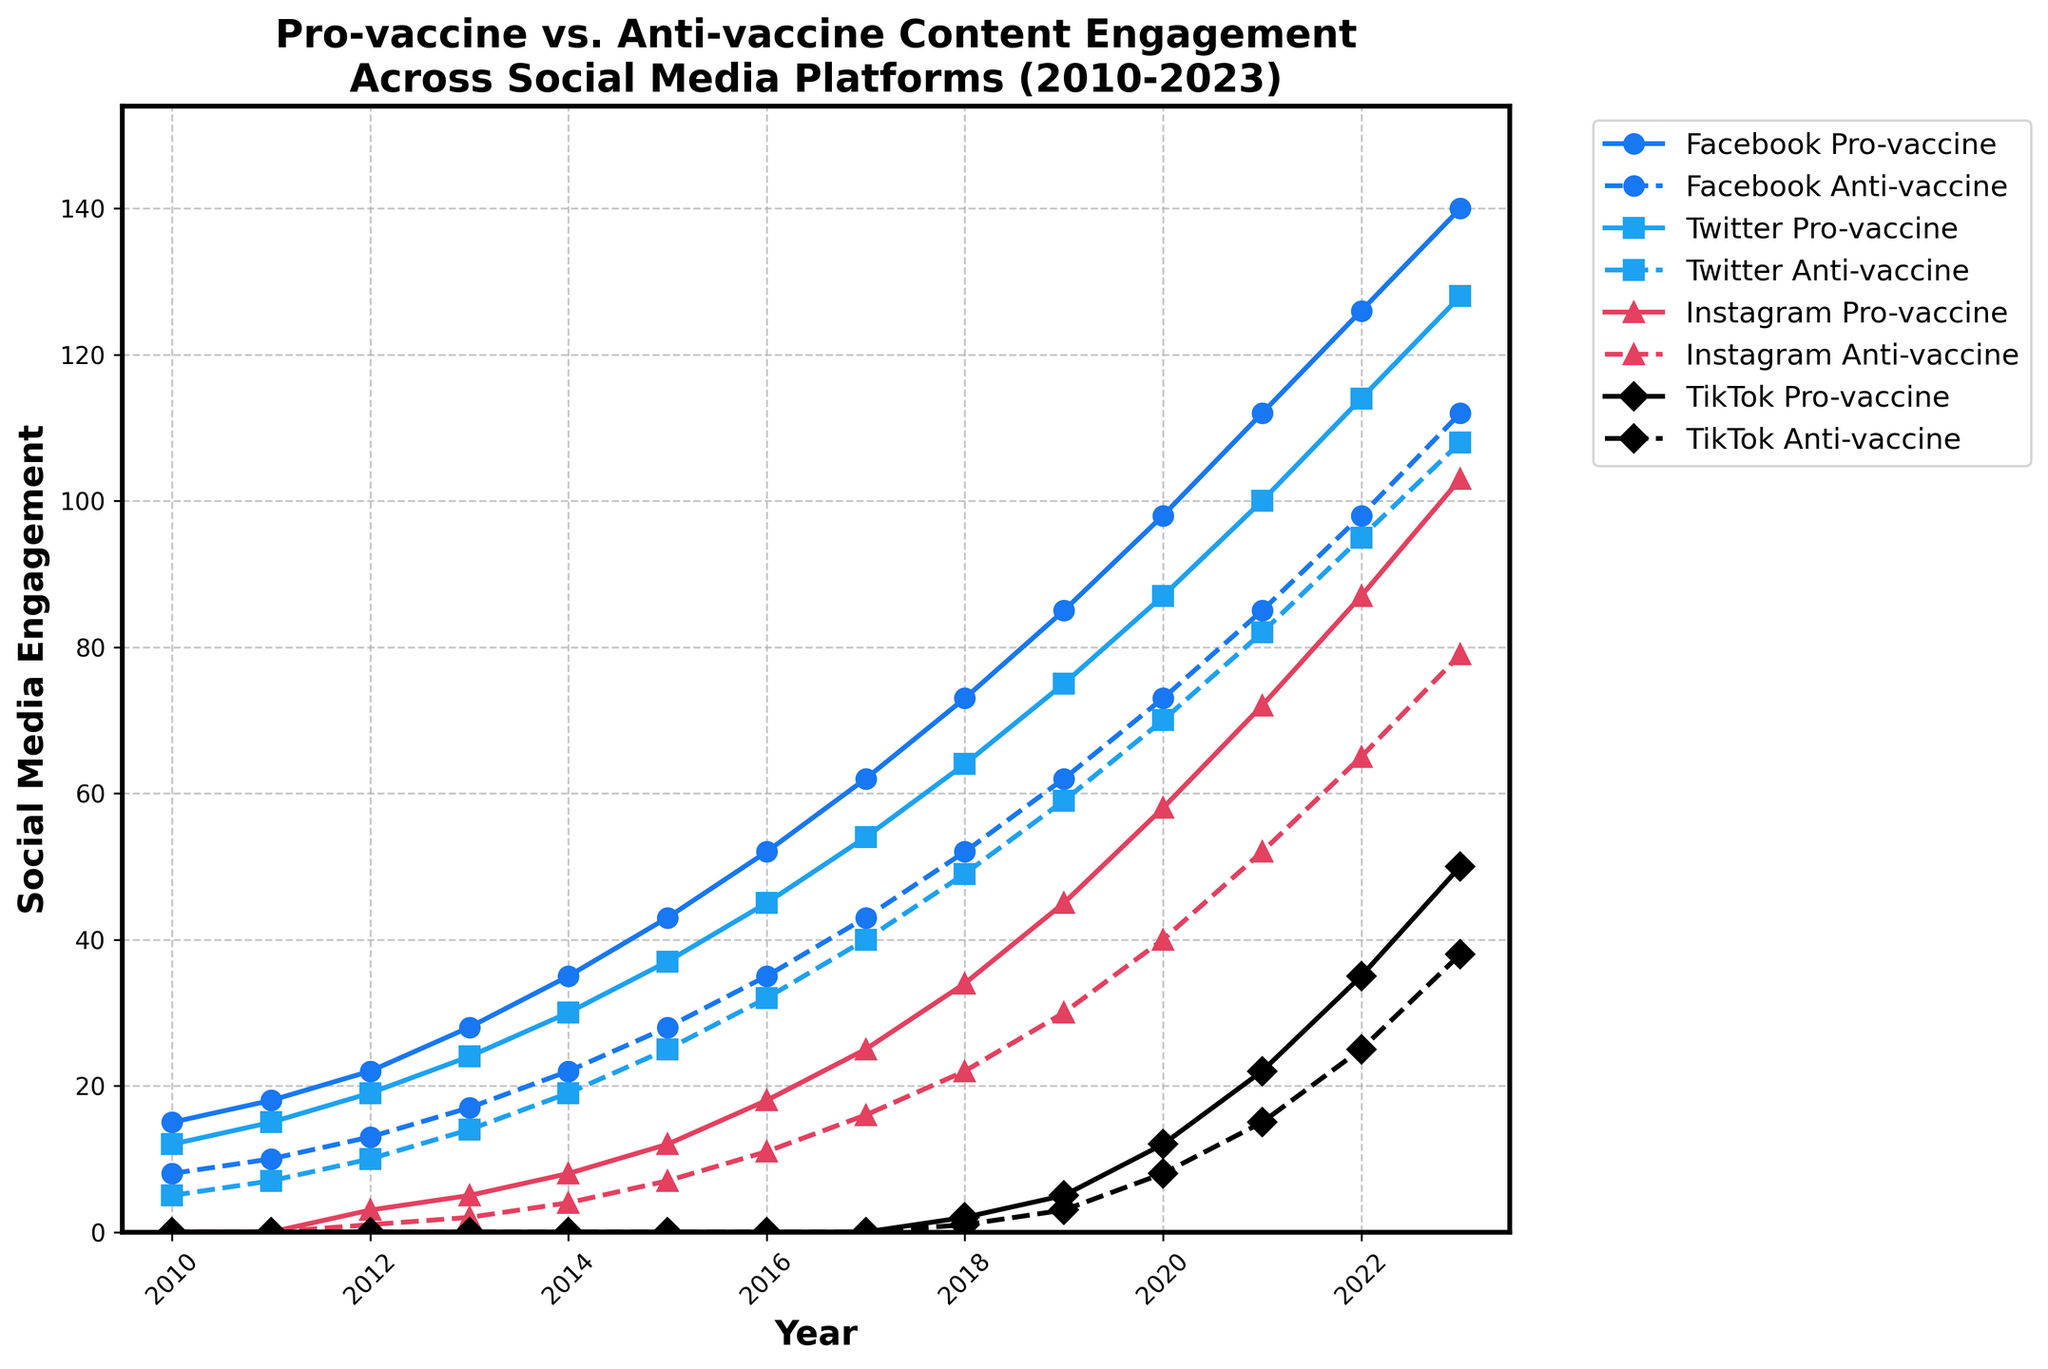What's the total social media engagement for pro-vaccine content on Facebook and Twitter in 2022? To calculate this, add the Facebook pro-vaccine engagement (126) to the Twitter pro-vaccine engagement (114). The total is 126 + 114 = 240.
Answer: 240 Which year saw the steepest increase in Instagram anti-vaccine engagements? Compare the yearly differences in Instagram anti-vaccine engagements. From 2020 to 2021, the increase is the highest: 52 (2021) - 40 (2020) = 12.
Answer: 2021 Between 2010 and 2023, in which year was Twitter pro-vaccine engagement first higher than the previous year's Facebook pro-vaccine engagement? Find when Twitter pro-vaccine surpasses the previous year's Facebook pro-vaccine. In 2012, Twitter pro-vaccine (19) is higher than Facebook pro-vaccine (2011) (18).
Answer: 2012 Which platform has the highest anti-vaccine engagement in 2023? Check the anti-vaccine engagements across all platforms in 2023 and find the maximum: TikTok Anti-vaccine (38) is the highest.
Answer: TikTok What is the average increase in Facebook pro-vaccine engagement per year between 2010 and 2023? Calculate the total increase over the years (140 - 15 = 125) and divide by the number of years (2023 - 2010 = 13). The average increase per year is 125 / 13 ≈ 9.62.
Answer: 9.62 